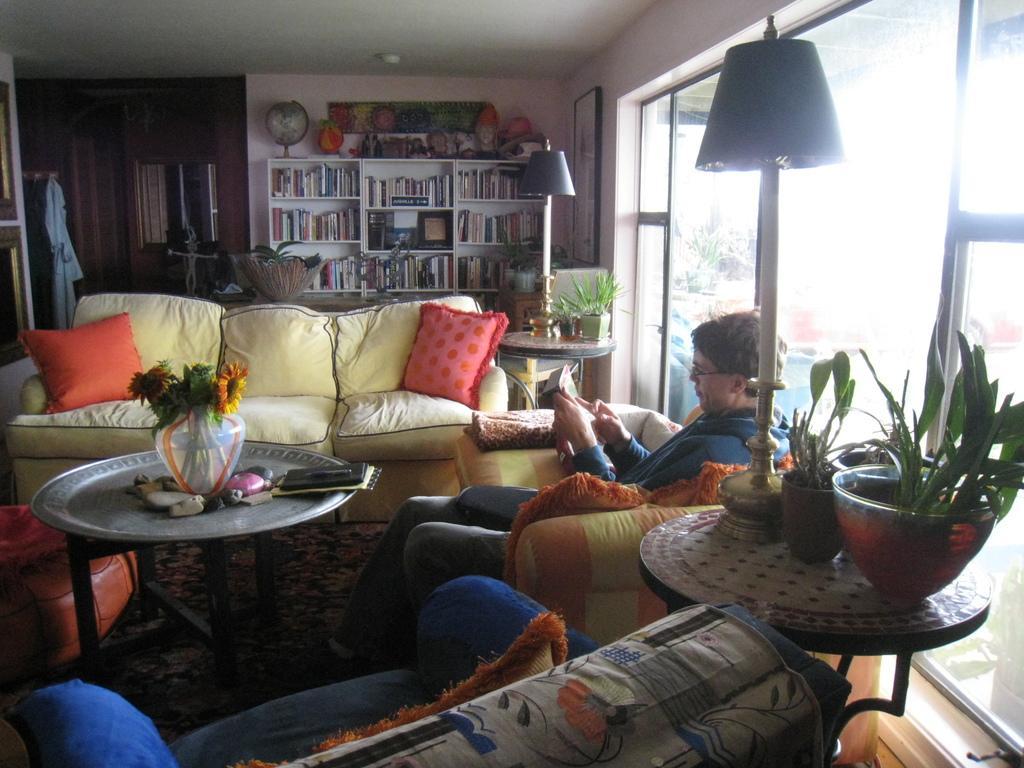Can you describe this image briefly? The image is inside the room. In the image there is a man who is sitting on couch and holding something. On right side of the image there is a table on table we can see a lamp,plants with flower pot and on left of the image we can see there is a couch,clothes,mirror. In middle of the image we can see a shelf on shelf there are some books,globe,couch on couch there are two pillows and a table and on table we can see a flower pot with some flowers,frames and a wall which is in pink color. 